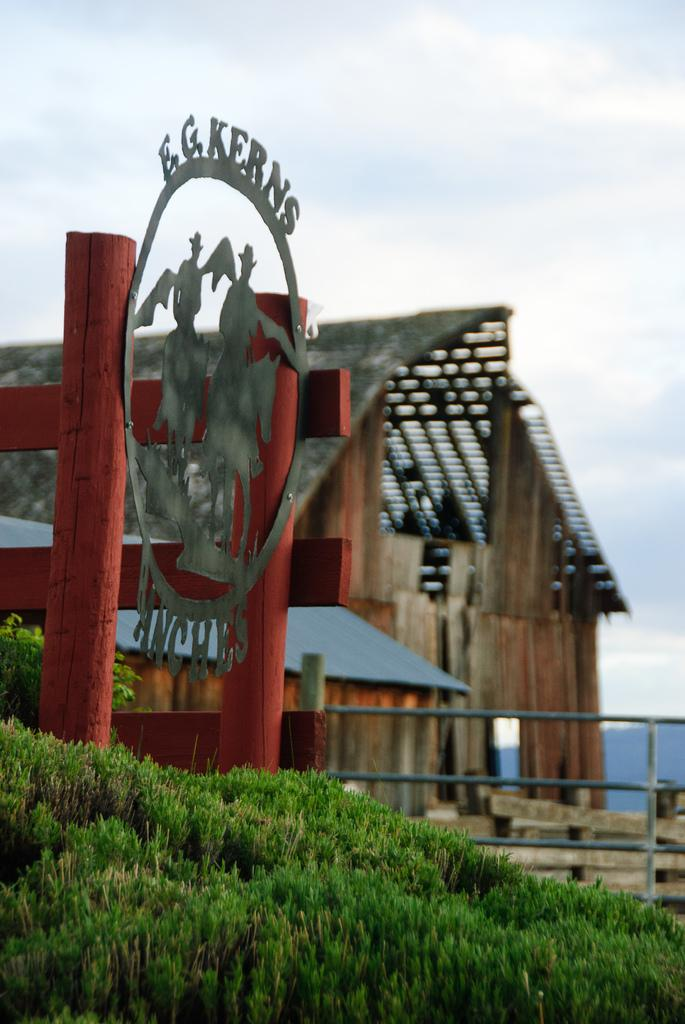<image>
Give a short and clear explanation of the subsequent image. E.G. Kerns Anches label on an old development. 